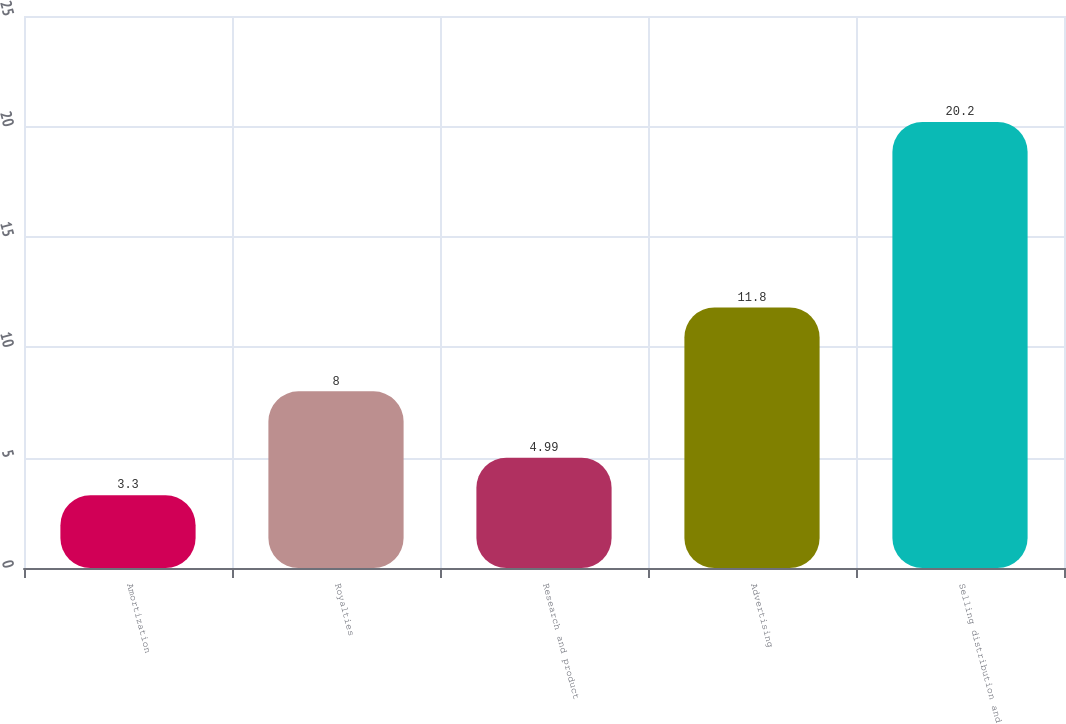Convert chart to OTSL. <chart><loc_0><loc_0><loc_500><loc_500><bar_chart><fcel>Amortization<fcel>Royalties<fcel>Research and product<fcel>Advertising<fcel>Selling distribution and<nl><fcel>3.3<fcel>8<fcel>4.99<fcel>11.8<fcel>20.2<nl></chart> 